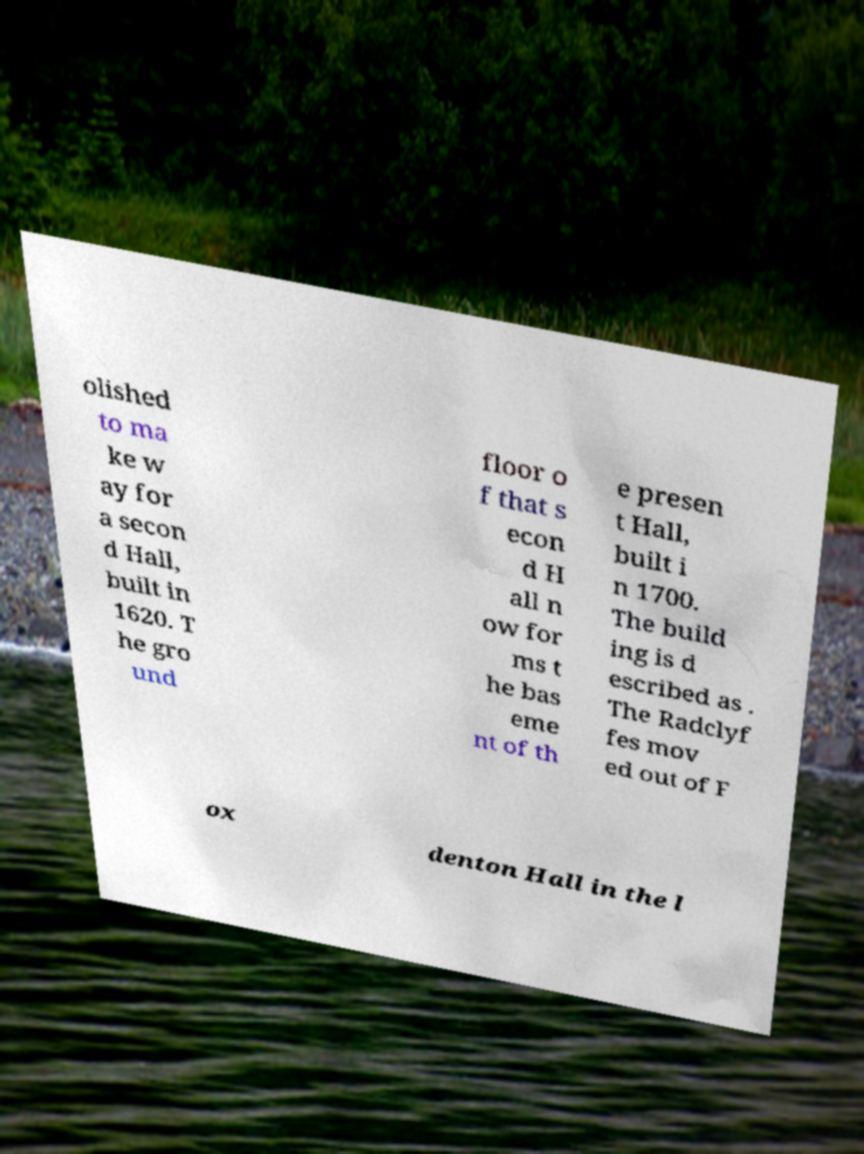Could you assist in decoding the text presented in this image and type it out clearly? olished to ma ke w ay for a secon d Hall, built in 1620. T he gro und floor o f that s econ d H all n ow for ms t he bas eme nt of th e presen t Hall, built i n 1700. The build ing is d escribed as . The Radclyf fes mov ed out of F ox denton Hall in the l 